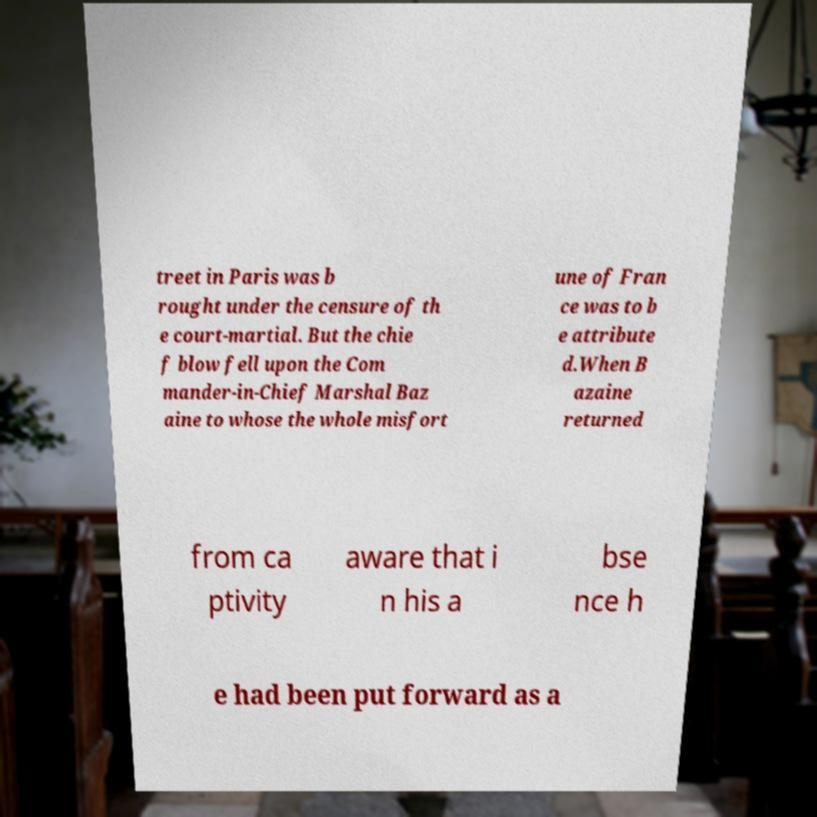There's text embedded in this image that I need extracted. Can you transcribe it verbatim? treet in Paris was b rought under the censure of th e court-martial. But the chie f blow fell upon the Com mander-in-Chief Marshal Baz aine to whose the whole misfort une of Fran ce was to b e attribute d.When B azaine returned from ca ptivity aware that i n his a bse nce h e had been put forward as a 